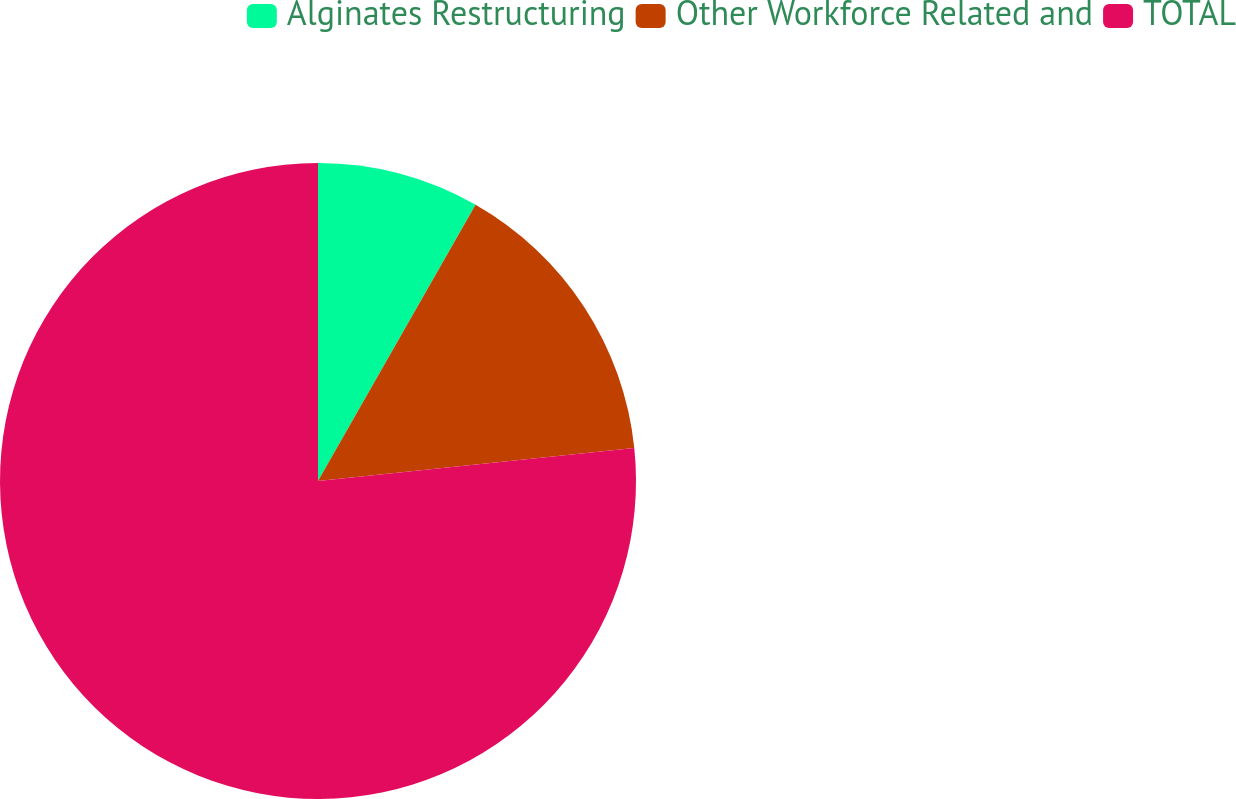Convert chart. <chart><loc_0><loc_0><loc_500><loc_500><pie_chart><fcel>Alginates Restructuring<fcel>Other Workforce Related and<fcel>TOTAL<nl><fcel>8.25%<fcel>15.09%<fcel>76.65%<nl></chart> 